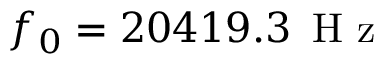<formula> <loc_0><loc_0><loc_500><loc_500>f _ { 0 } = 2 0 4 1 9 . 3 \, H z</formula> 